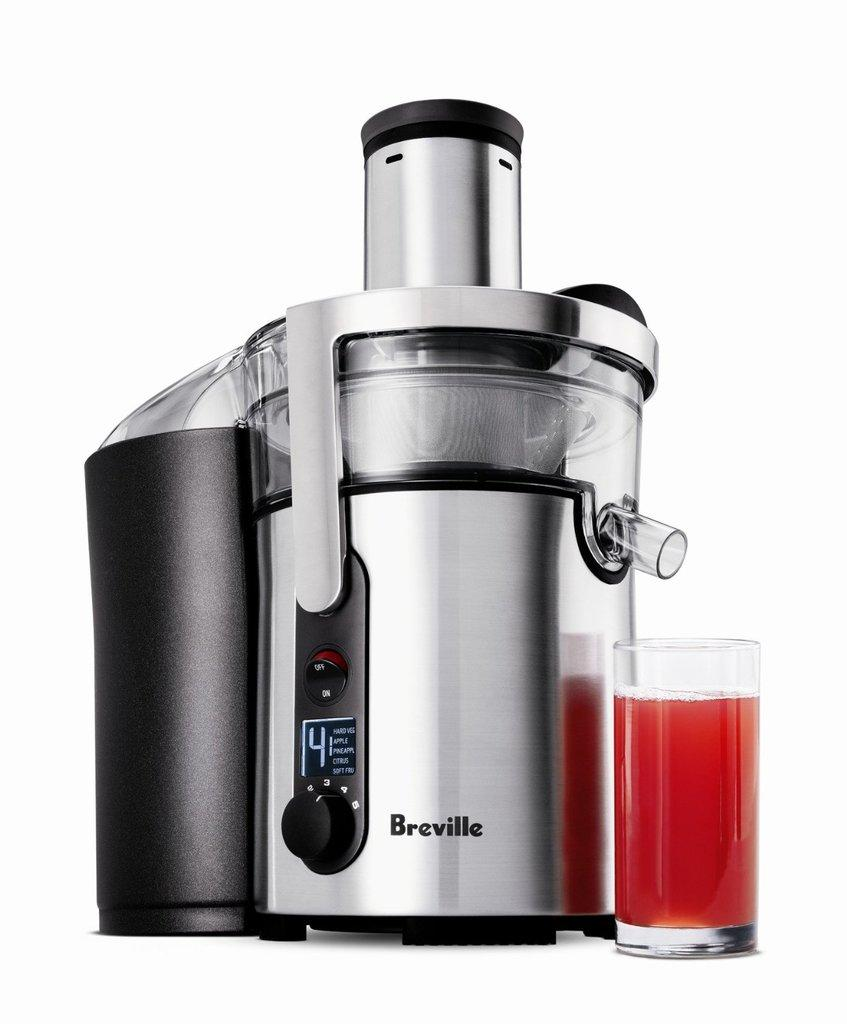<image>
Share a concise interpretation of the image provided. Breville juice is chrome and black with a red juice of some kind in front. 